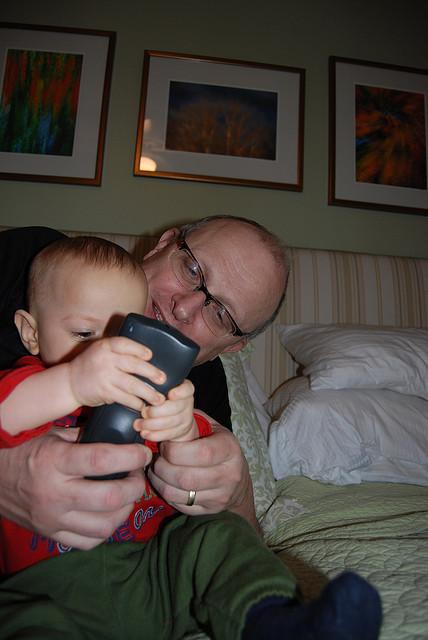What is the baby playing with? remote 